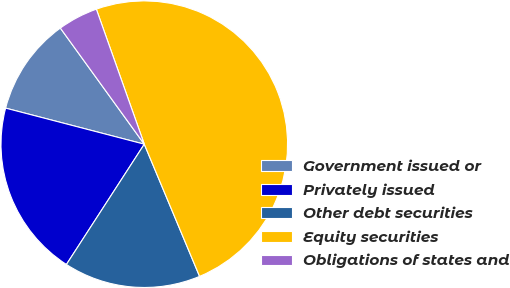Convert chart. <chart><loc_0><loc_0><loc_500><loc_500><pie_chart><fcel>Government issued or<fcel>Privately issued<fcel>Other debt securities<fcel>Equity securities<fcel>Obligations of states and<nl><fcel>10.99%<fcel>19.91%<fcel>15.45%<fcel>49.13%<fcel>4.53%<nl></chart> 